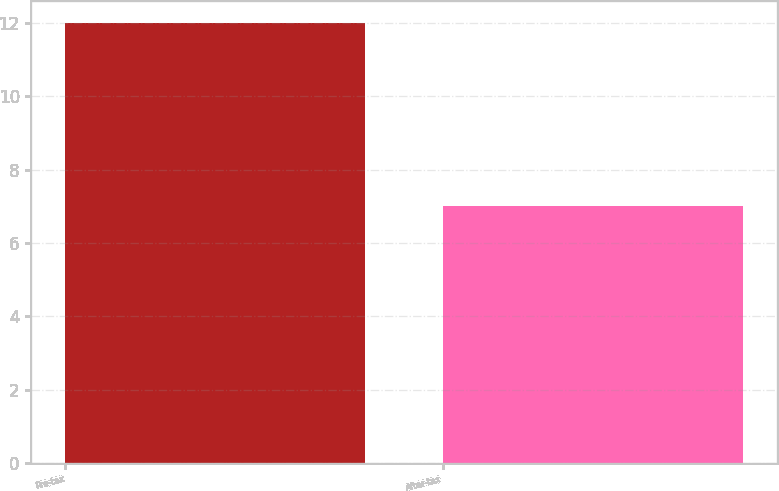Convert chart to OTSL. <chart><loc_0><loc_0><loc_500><loc_500><bar_chart><fcel>Pre-tax<fcel>After-tax<nl><fcel>12<fcel>7<nl></chart> 